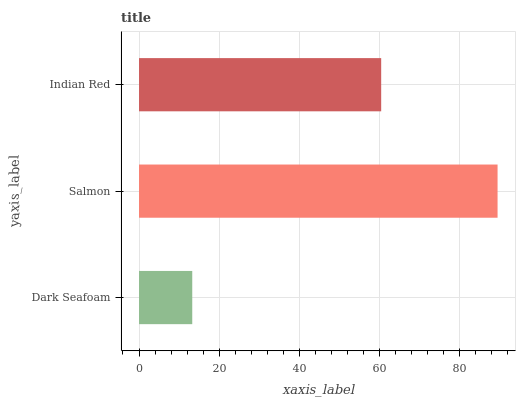Is Dark Seafoam the minimum?
Answer yes or no. Yes. Is Salmon the maximum?
Answer yes or no. Yes. Is Indian Red the minimum?
Answer yes or no. No. Is Indian Red the maximum?
Answer yes or no. No. Is Salmon greater than Indian Red?
Answer yes or no. Yes. Is Indian Red less than Salmon?
Answer yes or no. Yes. Is Indian Red greater than Salmon?
Answer yes or no. No. Is Salmon less than Indian Red?
Answer yes or no. No. Is Indian Red the high median?
Answer yes or no. Yes. Is Indian Red the low median?
Answer yes or no. Yes. Is Dark Seafoam the high median?
Answer yes or no. No. Is Dark Seafoam the low median?
Answer yes or no. No. 